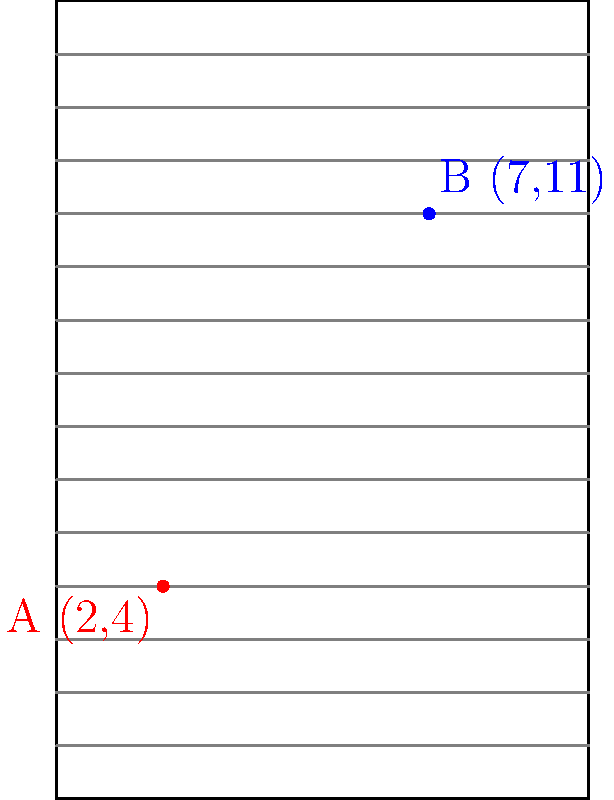In a crucial play during a football game, two players are positioned on the field as shown in the diagram. Player A is at coordinates (2,4) and Player B is at coordinates (7,11). What is the straight-line distance between these two players on the field? Round your answer to the nearest yard. To solve this problem, we'll use the distance formula derived from the Pythagorean theorem:

1) The distance formula is: $d = \sqrt{(x_2-x_1)^2 + (y_2-y_1)^2}$

2) We have:
   Player A: $(x_1, y_1) = (2, 4)$
   Player B: $(x_2, y_2) = (7, 11)$

3) Let's substitute these values into the formula:

   $d = \sqrt{(7-2)^2 + (11-4)^2}$

4) Simplify inside the parentheses:
   
   $d = \sqrt{5^2 + 7^2}$

5) Calculate the squares:
   
   $d = \sqrt{25 + 49}$

6) Add inside the square root:
   
   $d = \sqrt{74}$

7) Calculate the square root:
   
   $d \approx 8.602325267$

8) Rounding to the nearest yard:
   
   $d \approx 9$ yards

Therefore, the straight-line distance between the two players is approximately 9 yards.
Answer: 9 yards 